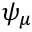Convert formula to latex. <formula><loc_0><loc_0><loc_500><loc_500>\psi _ { \mu }</formula> 